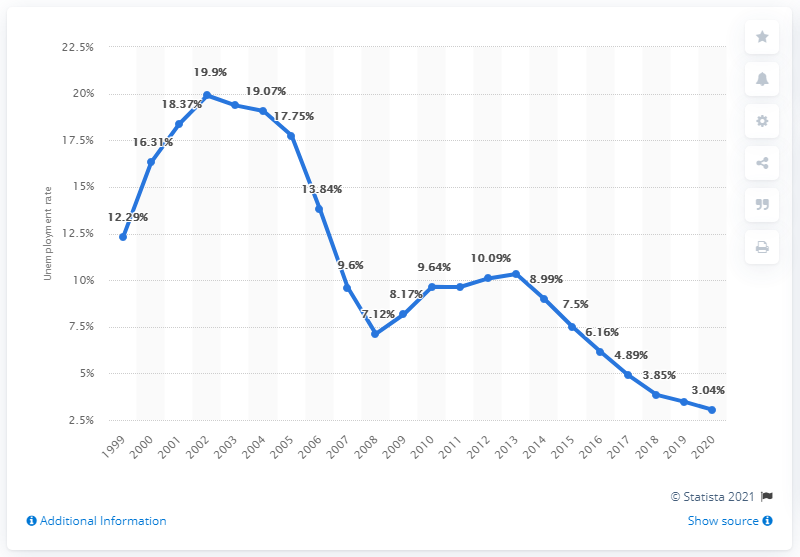Identify some key points in this picture. According to data from 2020, the unemployment rate in Poland was 3.04%. 